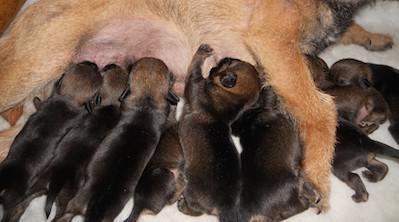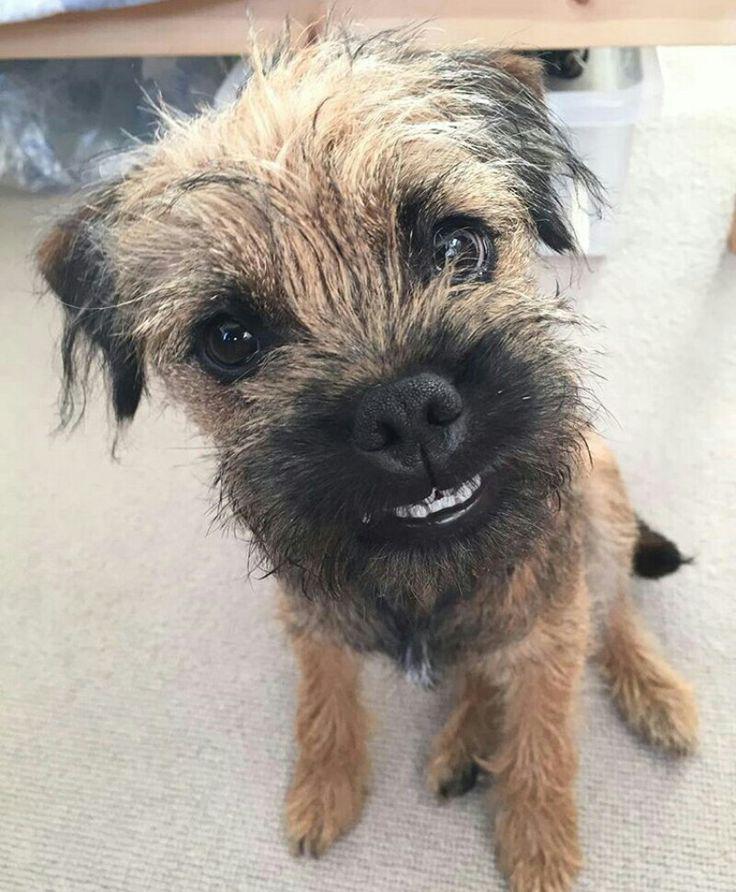The first image is the image on the left, the second image is the image on the right. Evaluate the accuracy of this statement regarding the images: "In the image to the right, there is but one dog.". Is it true? Answer yes or no. Yes. 